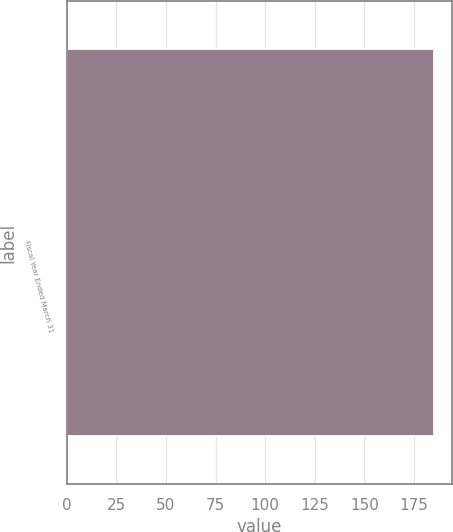<chart> <loc_0><loc_0><loc_500><loc_500><bar_chart><fcel>Fiscal Year Ended March 31<nl><fcel>185<nl></chart> 